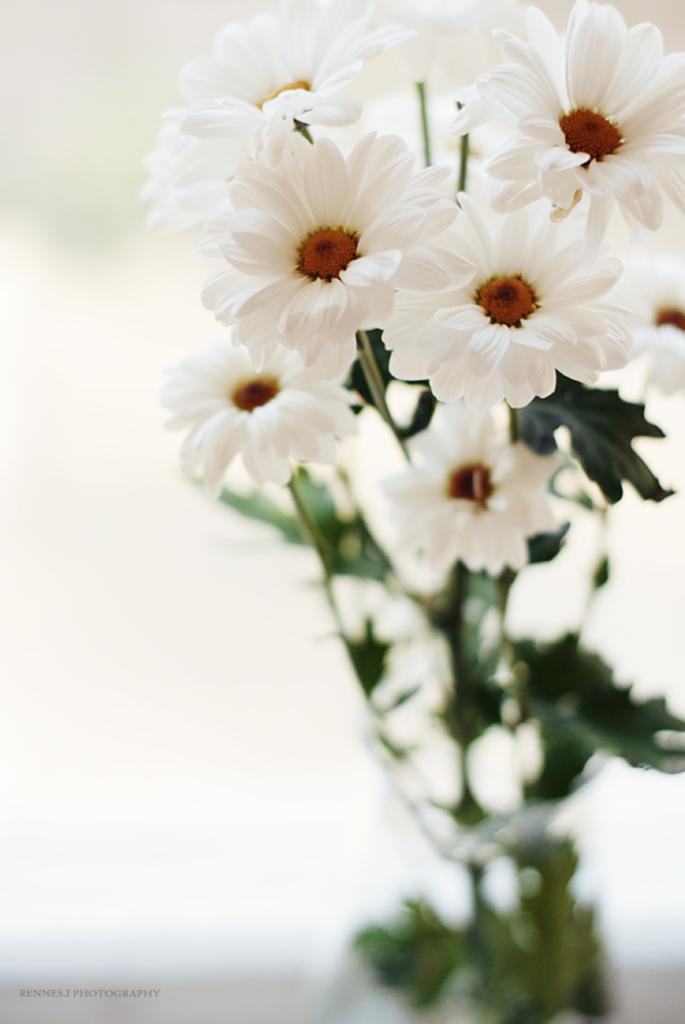Describe this image in one or two sentences. In this image we can see white flowers kept in the vase. Here the image is slightly blurred and the background of the image is white in color. Here we can see some edited text. 